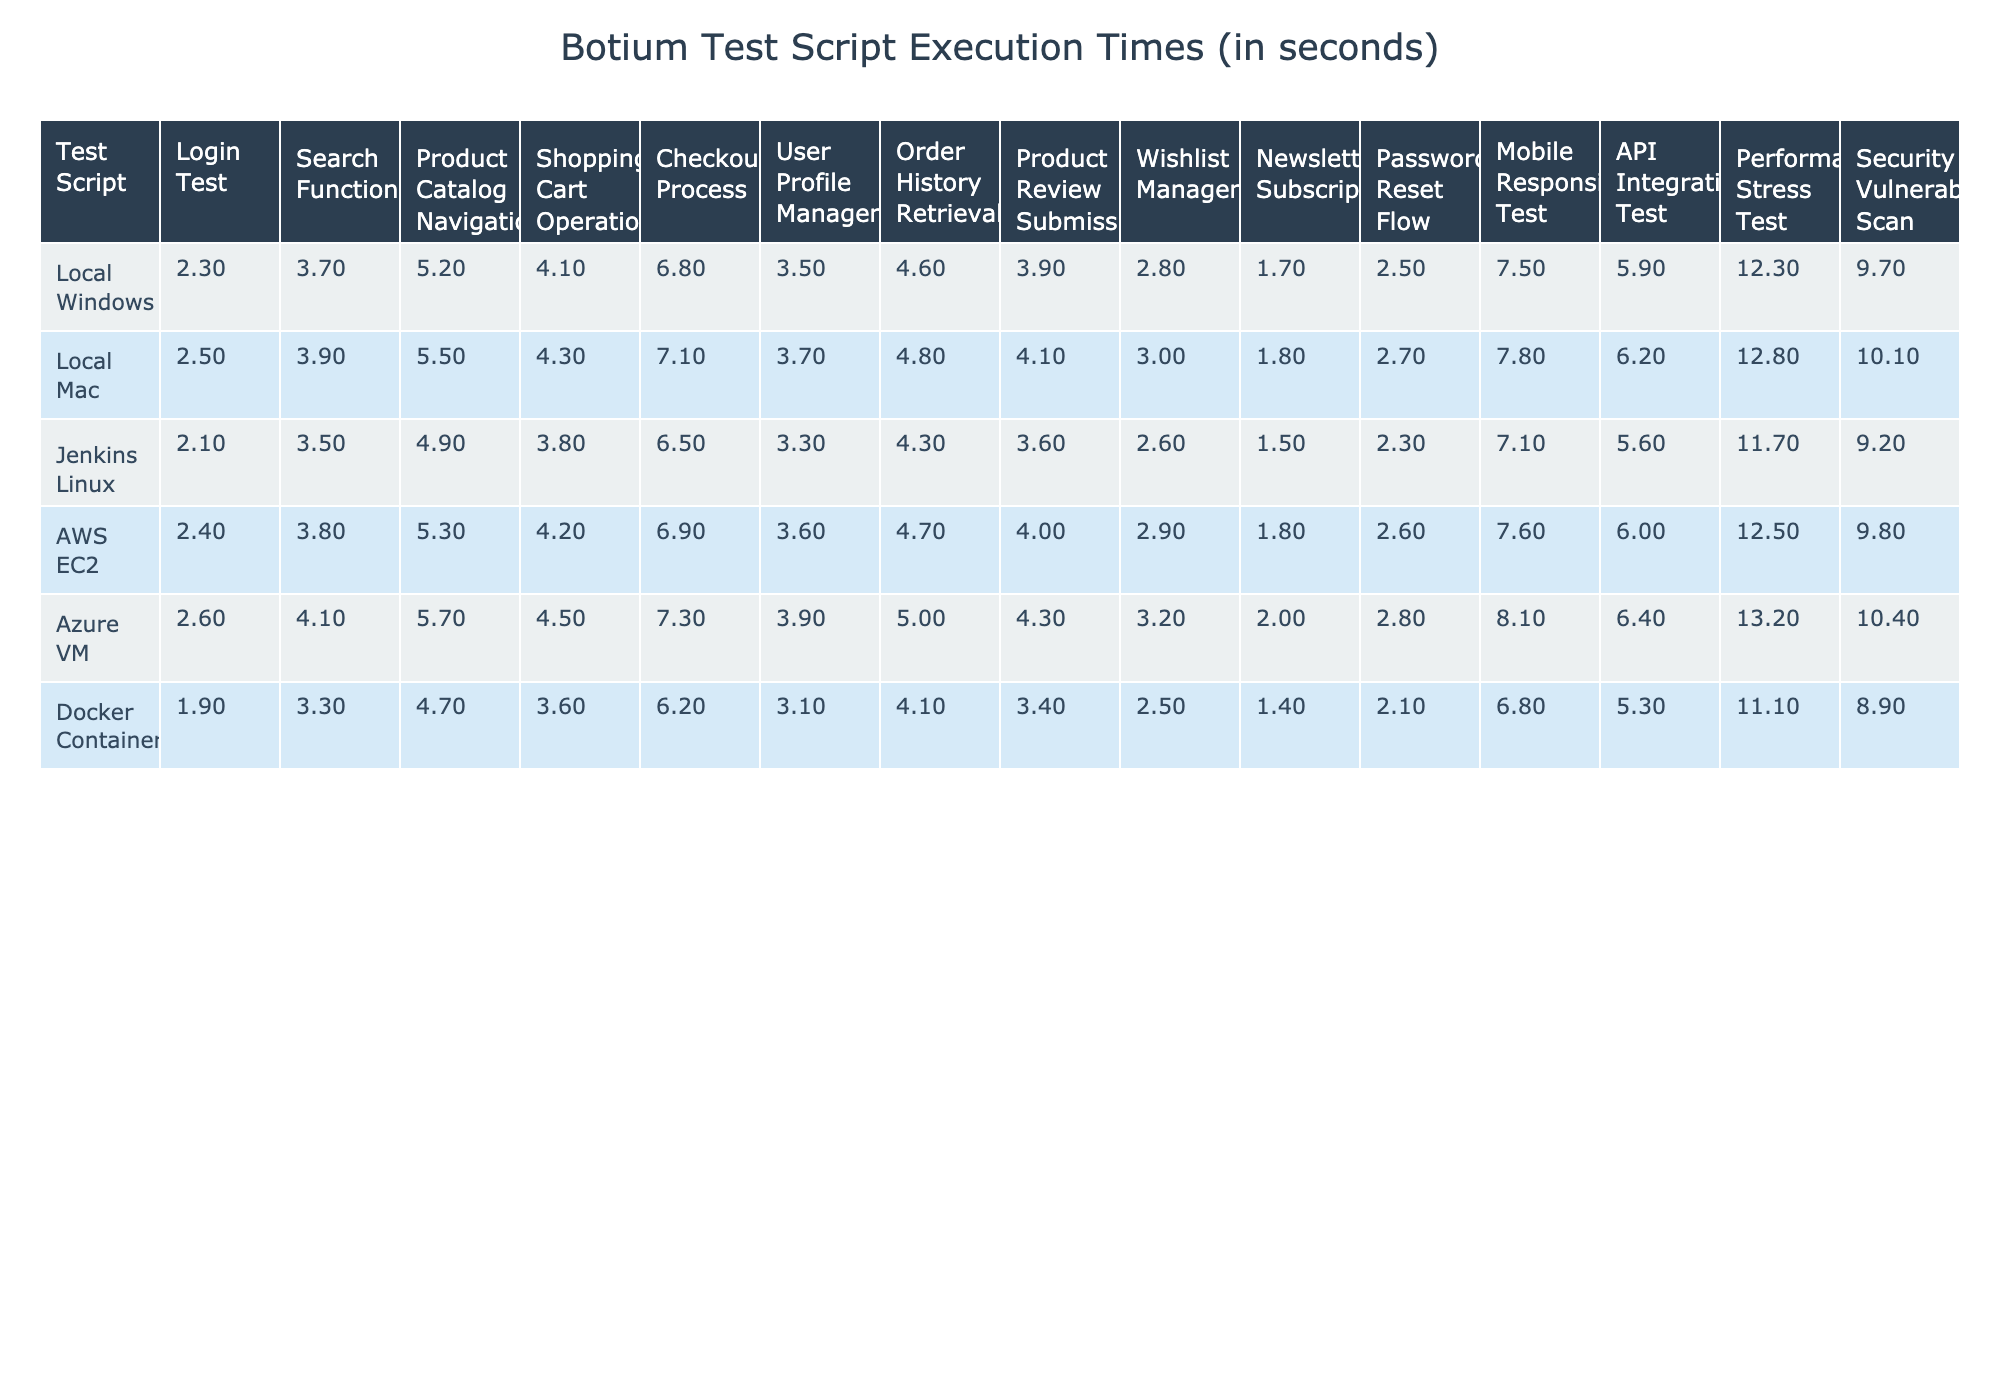What is the execution time of the Login Test in the AWS EC2 environment? According to the table, the Login Test takes 2.4 seconds in the AWS EC2 environment.
Answer: 2.4 seconds Which environment has the longest execution time for the Checkout Process? The longest execution time for the Checkout Process is in the Azure VM environment, which is 7.3 seconds, as displayed in the table.
Answer: Azure VM What is the difference in execution time for the Product Catalog Navigation test between the Local Mac and Docker Container environments? The execution time for Local Mac is 5.5 seconds and for Docker Container is 4.7 seconds. The difference is 5.5 - 4.7 = 0.8 seconds.
Answer: 0.8 seconds Is the execution time for the Newsletter Subscription test higher in Local Windows than in Docker Container? The execution time for Newsletter Subscription in Local Windows is 1.7 seconds, while in Docker Container it is 1.4 seconds. Since 1.7 is greater than 1.4, the statement is true.
Answer: Yes What is the average execution time of the Shopping Cart Operations across all environments? The execution times for Shopping Cart Operations are 4.1, 4.3, 3.8, 4.2, 4.5, and 3.6 seconds. The sum is 4.1 + 4.3 + 3.8 + 4.2 + 4.5 + 3.6 = 24.5 seconds, and there are 6 data points, so the average is 24.5 / 6 = 4.0833 seconds.
Answer: 4.08 seconds Which environment has the shortest execution time for the User Profile Management test? The shortest execution time for User Profile Management is found in the Docker Container environment, where it takes 3.1 seconds, as noted in the table.
Answer: Docker Container What is the maximum execution time for Performance Stress Test, and in which environment does it occur? The maximum execution time is 13.2 seconds, which occurs in the Azure VM environment. By checking the values in the table, 13.2 is identified as the highest.
Answer: 13.2 seconds in Azure VM How many tests have an execution time over 6 seconds in the Local Windows environment? In the Local Windows environment, the tests with execution times over 6 seconds are Checkout Process (6.8), Mobile Responsiveness Test (7.5), Performance Stress Test (12.3), and Security Vulnerability Scan (9.7). That's a total of 4 tests.
Answer: 4 tests What is the average execution time for all tests in the Jenkins Linux environment? The execution times in the Jenkins Linux environment are 2.1, 3.5, 4.9, 3.8, 6.5, 3.3, 4.3, 3.6, 2.6, 1.5, 2.3, 7.1, 5.6, 11.7, and 9.2 seconds. The sum is 63.5 seconds for the 15 tests, so the average is 63.5 / 15 = 4.2333 seconds.
Answer: 4.23 seconds Which test has the least execution time in the Local Mac environment? The test with the least execution time in the Local Mac environment is the Newsletter Subscription test, which takes 1.8 seconds according to the table.
Answer: Newsletter Subscription 